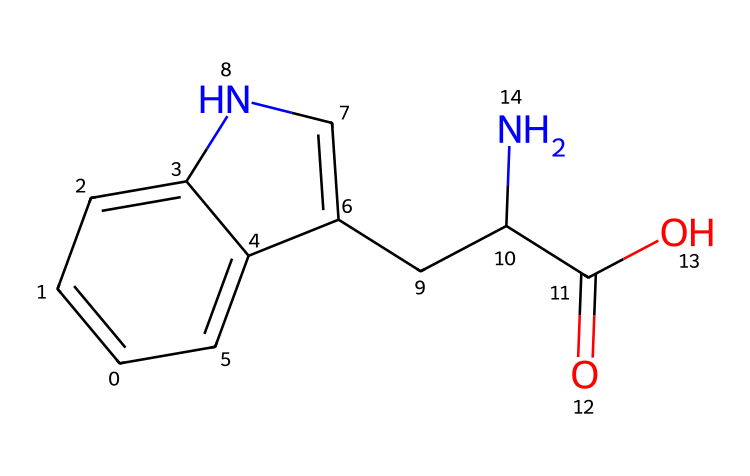What is the molecular formula of the chemical represented by the SMILES? By analyzing the components of the SMILES representation, we can count the number of each element present: there are 11 carbon atoms (C), 12 hydrogen atoms (H), 2 nitrogen atoms (N), and 2 oxygen atoms (O). Thus, the molecular formula is C11H12N2O2.
Answer: C11H12N2O2 How many rings are present in the structure? Looking at the SMILES, we can identify two ring structures denoted by the numbers in the notation. The first and second rings are represented by the numbers '1' and '2', indicating two interconnected rings.
Answer: 2 What type of functional group is present in this structure? The structure has a carboxylic acid functional group (-COOH) visible from the 'C(=O)O' part of the SMILES, which specifies the presence of a carbonyl (C=O) and a hydroxyl (OH) group.
Answer: carboxylic acid Is there any chirality in this molecule? Reviewing the structure, the presence of an asymmetric carbon atom (the carbon atom connected to four different groups) implies chirality. Upon examination of the segments attached to this carbon, it indicates that the molecule is chiral.
Answer: yes What are the possible uses of tryptophan linked to relaxation? Tryptophan is often used in dietary supplements to promote relaxation and improve sleep quality due to its role as a precursor to serotonin, a neurotransmitter that regulates mood.
Answer: relaxation, sleep quality How many nitrogen atoms are there in the structure? Counting the occurrences of 'N' in the SMILES representation reveals two nitrogen atoms are present in the structure of tryptophan.
Answer: 2 